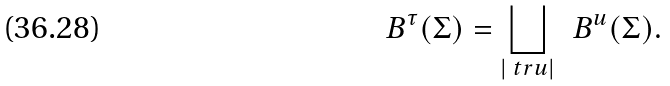Convert formula to latex. <formula><loc_0><loc_0><loc_500><loc_500>\ B ^ { \tau } ( \Sigma ) = \bigsqcup _ { | \ t r u | } \, \ B ^ { u } ( \Sigma ) .</formula> 